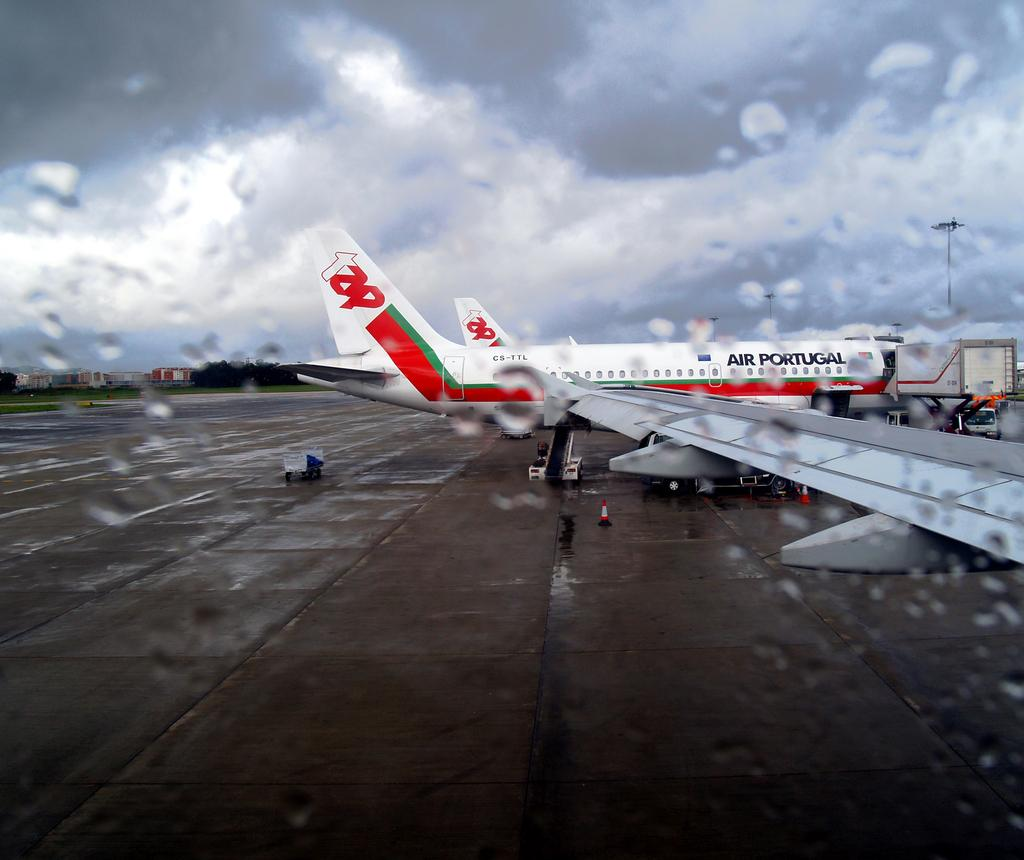What is the main subject of the image? The main subject of the image is an airplane. What feature can be seen on the airplane? The airplane has a wing. What else is present in the image besides the airplane? There are vehicles, traffic cones, trees, buildings, and the sky visible in the image. What can be seen in the sky in the image? Clouds are present in the sky. Can you tell me how many apples are being transported in the crate in the image? There is no crate or apples present in the image. What type of squirrel can be seen climbing the tree in the image? There is no squirrel visible in the image; only trees are present in the background. 